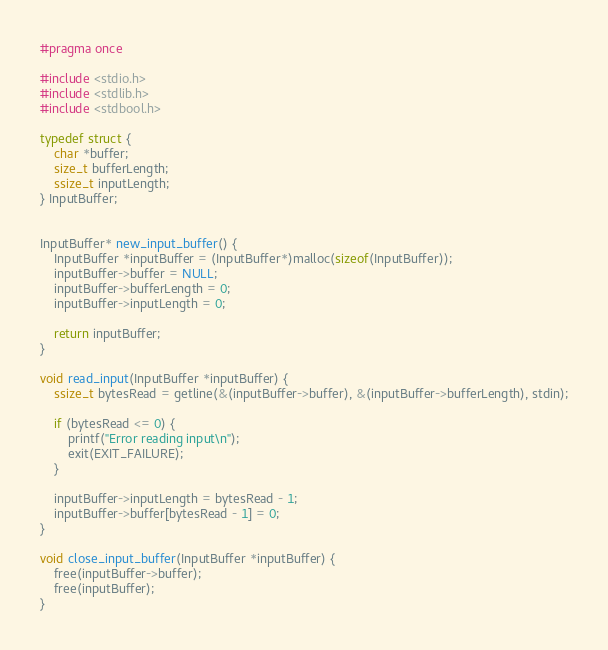<code> <loc_0><loc_0><loc_500><loc_500><_C_>#pragma once

#include <stdio.h>
#include <stdlib.h>
#include <stdbool.h>

typedef struct {
    char *buffer;
    size_t bufferLength;
    ssize_t inputLength;
} InputBuffer;


InputBuffer* new_input_buffer() {
    InputBuffer *inputBuffer = (InputBuffer*)malloc(sizeof(InputBuffer));
    inputBuffer->buffer = NULL;
    inputBuffer->bufferLength = 0;
    inputBuffer->inputLength = 0;

    return inputBuffer;
}

void read_input(InputBuffer *inputBuffer) {
    ssize_t bytesRead = getline(&(inputBuffer->buffer), &(inputBuffer->bufferLength), stdin);

    if (bytesRead <= 0) {
        printf("Error reading input\n");
        exit(EXIT_FAILURE);
    }

    inputBuffer->inputLength = bytesRead - 1;
    inputBuffer->buffer[bytesRead - 1] = 0;
}

void close_input_buffer(InputBuffer *inputBuffer) {
    free(inputBuffer->buffer);
    free(inputBuffer);
}</code> 